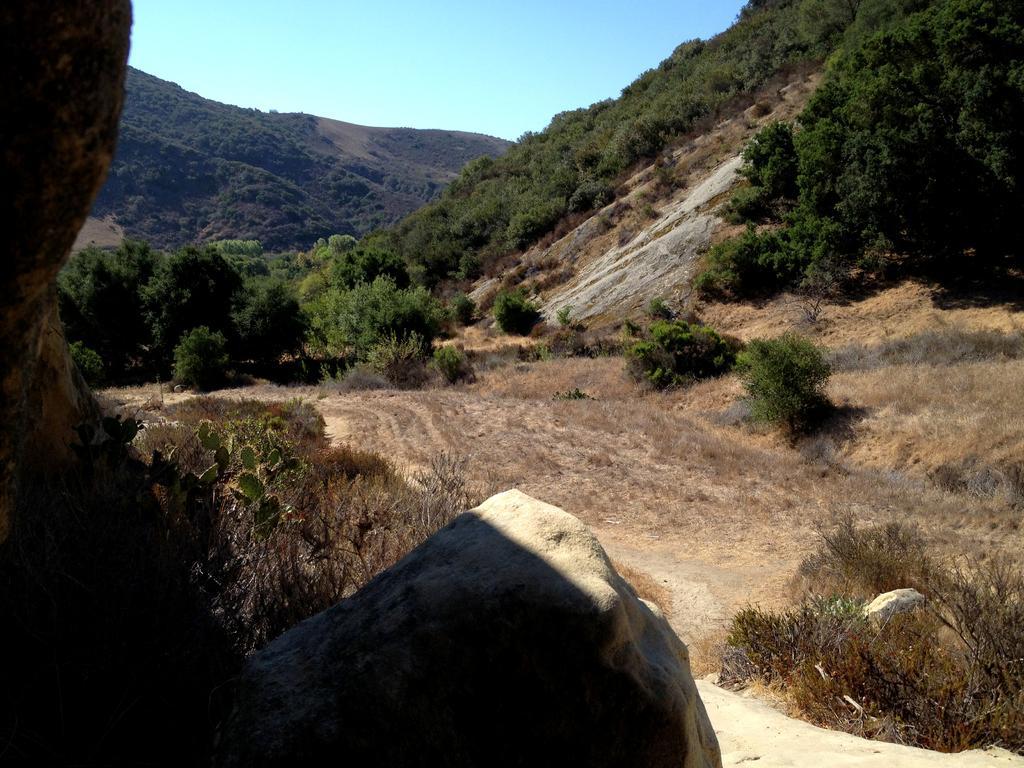How would you summarize this image in a sentence or two? In this image, we can see the ground. We can see some grass, plants and trees. We can also see some rocks and hills. We can see the sky. 